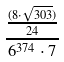<formula> <loc_0><loc_0><loc_500><loc_500>\frac { \frac { ( 8 \cdot \sqrt { 3 0 3 } ) } { 2 4 } } { 6 ^ { 3 7 4 } \cdot 7 }</formula> 